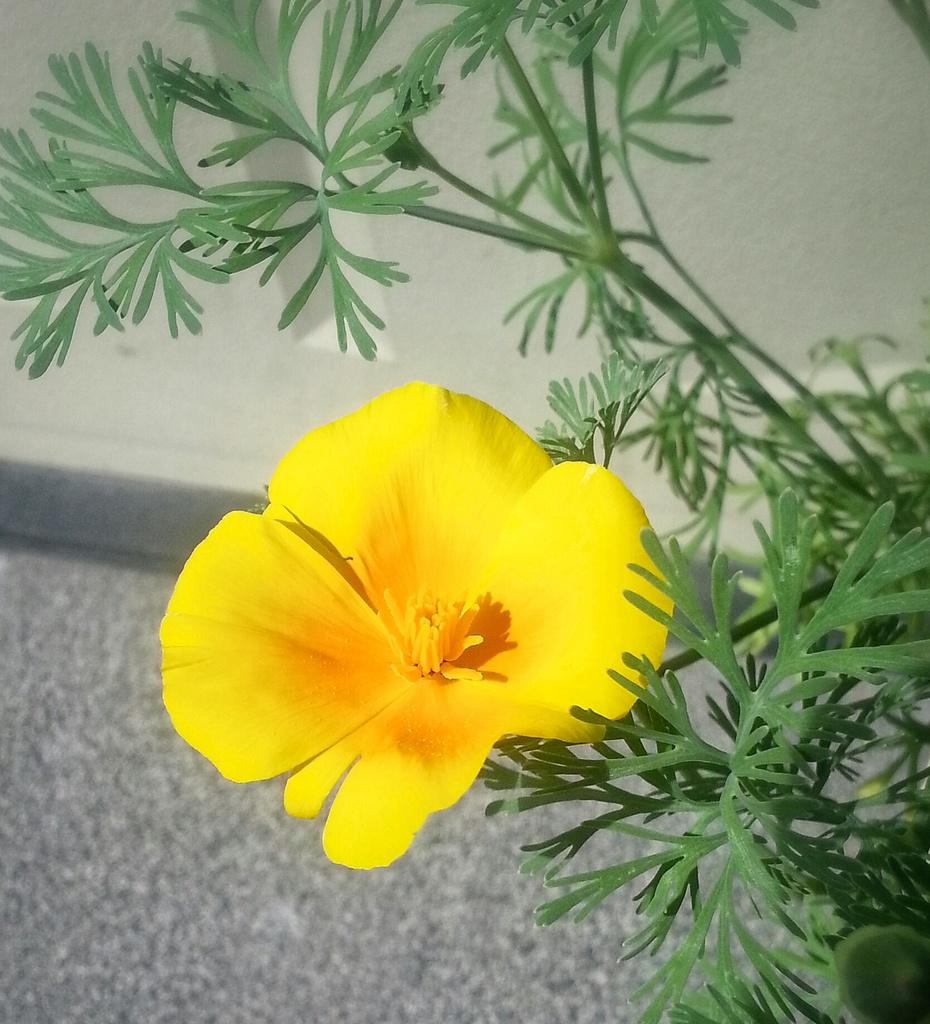What type of plant can be seen in the image? There is a plant with a flower in the image. What is visible in the background of the image? There is a wall in the background of the image. What grade did the plant receive for its performance in the image? There is no grade given to the plant in the image, as plants do not receive grades. 